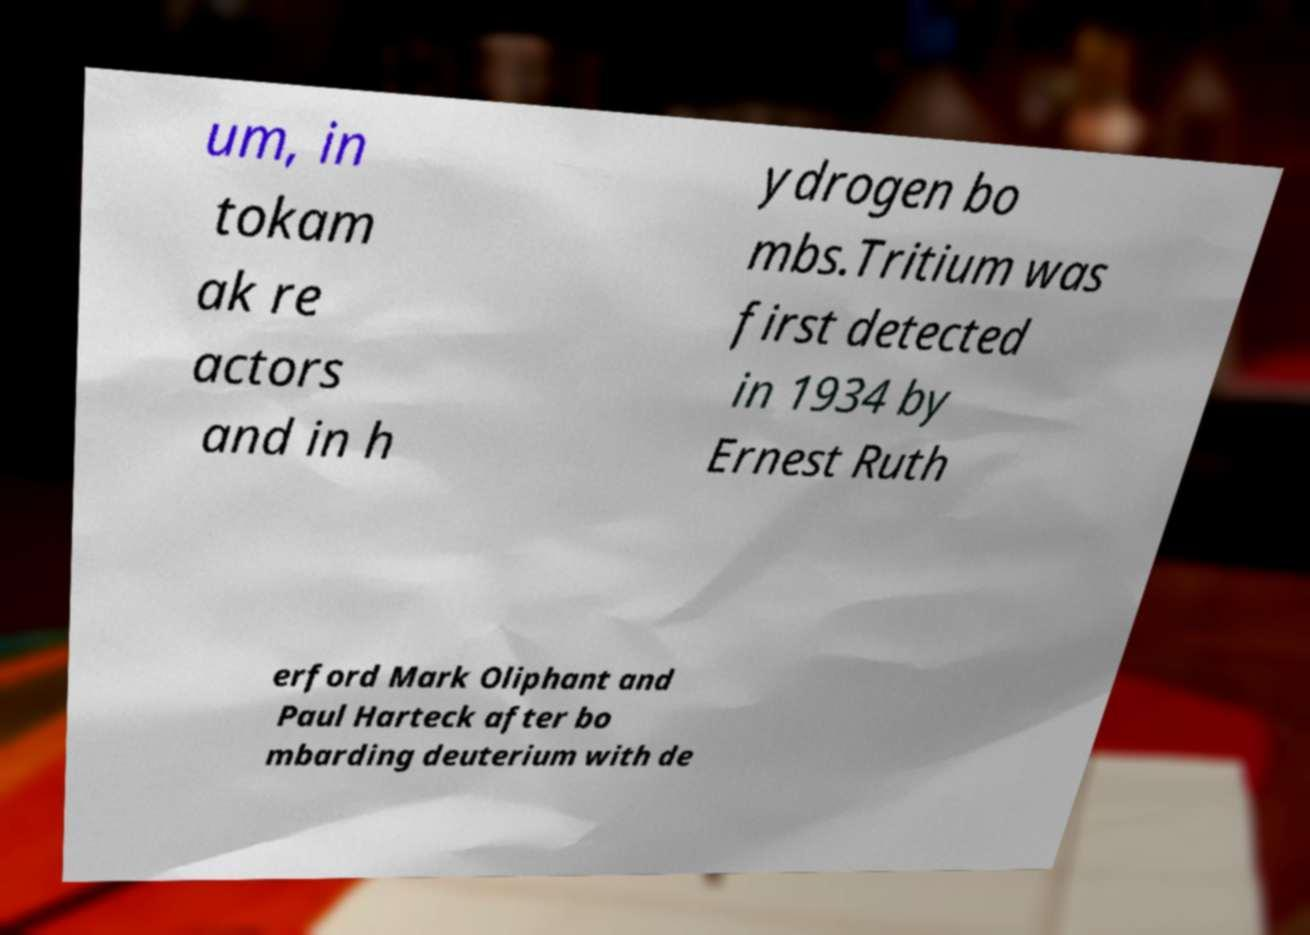Can you read and provide the text displayed in the image?This photo seems to have some interesting text. Can you extract and type it out for me? um, in tokam ak re actors and in h ydrogen bo mbs.Tritium was first detected in 1934 by Ernest Ruth erford Mark Oliphant and Paul Harteck after bo mbarding deuterium with de 